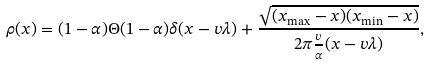<formula> <loc_0><loc_0><loc_500><loc_500>\rho ( x ) = ( 1 - \alpha ) \Theta ( 1 - \alpha ) \delta ( x - v \lambda ) + \frac { \sqrt { ( x _ { \max } - x ) ( x _ { \min } - x ) } } { 2 \pi \frac { v } { \alpha } ( x - v \lambda ) } ,</formula> 